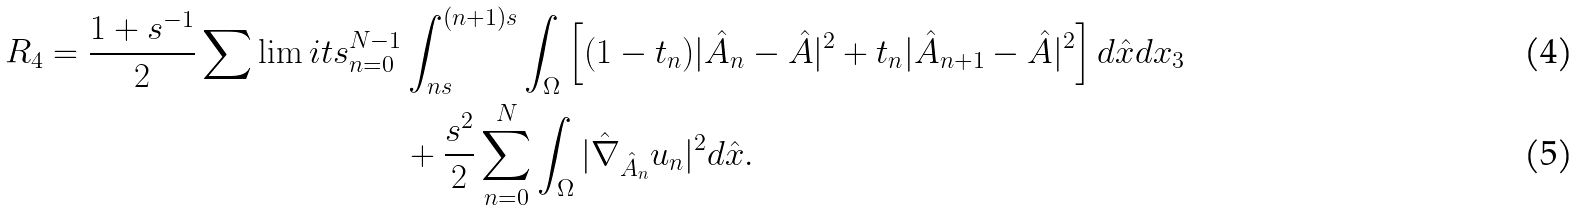<formula> <loc_0><loc_0><loc_500><loc_500>R _ { 4 } = \frac { 1 + s ^ { - 1 } } { 2 } \sum \lim i t s _ { n = 0 } ^ { N - 1 } & \int _ { n s } ^ { ( n + 1 ) s } \int _ { \Omega } \left [ ( 1 - t _ { n } ) | \hat { A } _ { n } - \hat { A } | ^ { 2 } + t _ { n } | \hat { A } _ { n + 1 } - \hat { A } | ^ { 2 } \right ] d \hat { x } d x _ { 3 } \\ & + \frac { s ^ { 2 } } { 2 } \sum ^ { N } _ { n = 0 } \int _ { \Omega } | \hat { \nabla } _ { \hat { A } _ { n } } u _ { n } | ^ { 2 } d \hat { x } .</formula> 